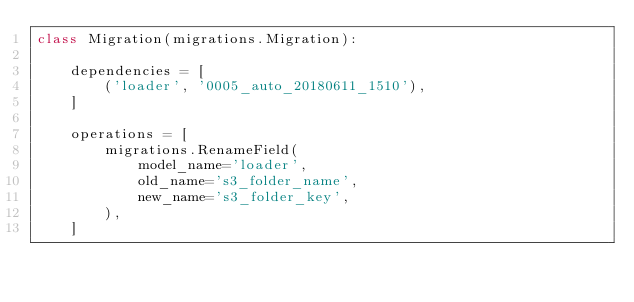<code> <loc_0><loc_0><loc_500><loc_500><_Python_>class Migration(migrations.Migration):

    dependencies = [
        ('loader', '0005_auto_20180611_1510'),
    ]

    operations = [
        migrations.RenameField(
            model_name='loader',
            old_name='s3_folder_name',
            new_name='s3_folder_key',
        ),
    ]
</code> 